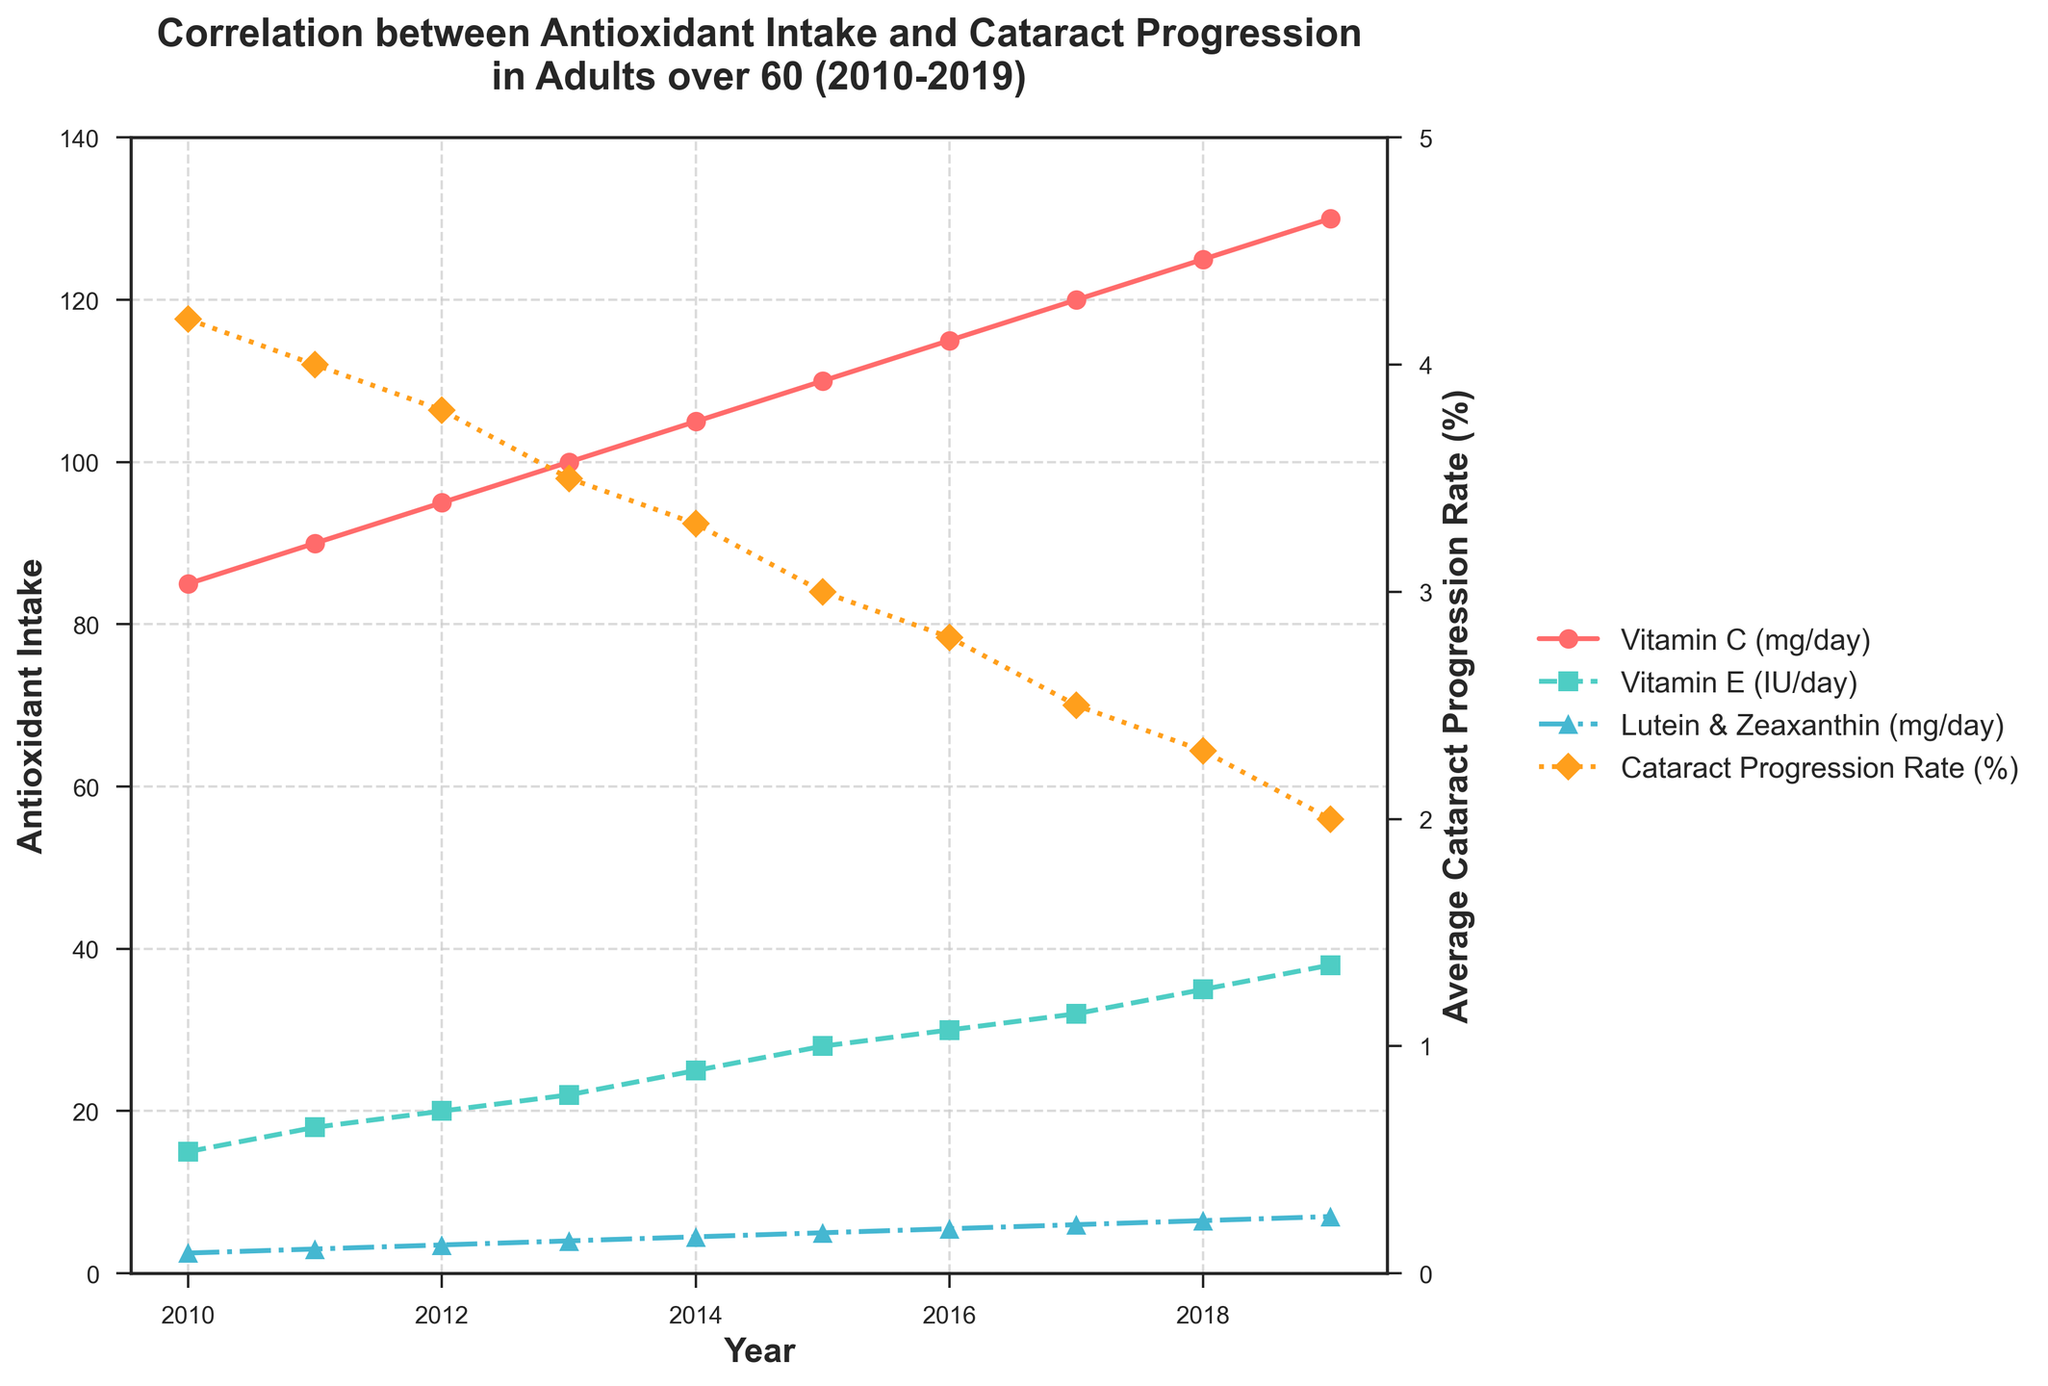What's the difference in Vitamin C intake between 2010 and 2019? To find the difference in Vitamin C intake, subtract the intake in 2010 from the intake in 2019: 130 mg/day (2019) - 85 mg/day (2010) = 45 mg/day
Answer: 45 mg/day What year saw the highest average cataract progression rate? To determine the highest average cataract progression rate, look at the values on the line representing cataract progression. The peak value in 2010 is 4.2%.
Answer: 2010 What's the total increase in Lutein & Zeaxanthin intake over the decade? To find the total increase, subtract the intake in 2010 from the intake in 2019: 7.0 mg/day (2019) - 2.5 mg/day (2010) = 4.5 mg/day
Answer: 4.5 mg/day In which year did Vitamin E intake (IU/day) surpass 30 IU/day? Locate the line representing Vitamin E intake and find the year when the values first exceed 30 IU/day. In 2016, the intake was 30 IU/day, but in 2017 it was 32 IU/day. Therefore, 2017 is the first year it surpassed 30 IU/day.
Answer: 2017 Is there a trend in the average cataract progression rate between 2010 and 2019? Observe the line representing cataract progression rate over the years. It shows a clear downward trend, indicating a consistent decrease over this period.
Answer: Downward trend Which antioxidant shows the greatest absolute increase in intake over the decade? Compare the increase for each antioxidant:
- Vitamin C: 130 mg/day (2019) - 85 mg/day (2010) = 45 mg/day
- Vitamin E: 38 IU/day (2019) - 15 IU/day (2010) = 23 IU/day
- Lutein & Zeaxanthin: 7.0 mg/day (2019) - 2.5 mg/day (2010) = 4.5 mg/day
Vitamin C has the greatest absolute increase.
Answer: Vitamin C What's the correlation between increased Vitamin C intake and cataract progression rate over the decade? As Vitamin C intake increases from 85 mg/day to 130 mg/day from 2010 to 2019, the average cataract progression rate decreases from 4.2% to 2.0%. This suggests a negative correlation: as Vitamin C intake increases, cataract progression rate decreases.
Answer: Negative correlation During which years did all three antioxidants see a higher intake than the previous year? Identify the years when the intake of Vitamin C, Vitamin E, and Lutein & Zeaxanthin all increased compared to the previous year. This happened every year from 2010 to 2019.
Answer: 2010-2019 What year did the average cataract progression drop below 3%? Look at the cataract progression rate line and identify the first year it dropped below 3%. It first drops below 3% in 2015 with a rate of 2.8%.
Answer: 2016 